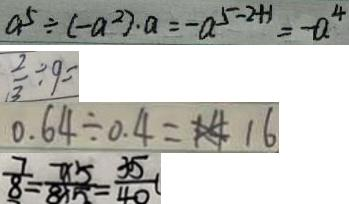Convert formula to latex. <formula><loc_0><loc_0><loc_500><loc_500>a ^ { 5 } \div ( - a ^ { 2 } ) \cdot a = - a ^ { 5 - 2 + 1 } = - a ^ { 4 } 
 \frac { 2 } { 3 } \div 9 = 
 0 . 6 4 \div 0 . 4 = 1 6 
 \frac { 7 } { 8 } = \frac { 7 \times 5 } { 8 \times 5 } = \frac { 3 5 } { 4 0 }</formula> 